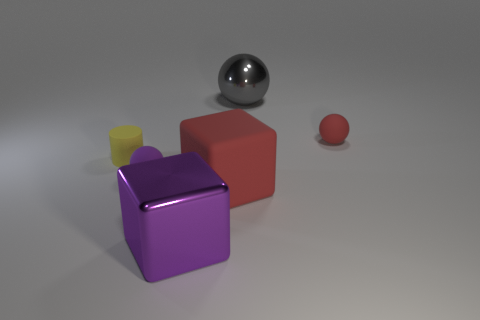Is the size of the purple rubber sphere the same as the purple block?
Keep it short and to the point. No. Is there a red matte thing of the same size as the yellow rubber thing?
Your answer should be compact. Yes. There is a ball to the left of the big matte cube; what is its material?
Offer a very short reply. Rubber. The cube that is made of the same material as the small red thing is what color?
Ensure brevity in your answer.  Red. How many shiny things are either purple cubes or large cyan spheres?
Provide a succinct answer. 1. There is a red matte object that is the same size as the gray ball; what is its shape?
Provide a succinct answer. Cube. What number of objects are either small things that are on the left side of the red block or big things that are in front of the tiny yellow cylinder?
Provide a succinct answer. 4. There is a gray thing that is the same size as the metallic cube; what material is it?
Ensure brevity in your answer.  Metal. How many other things are made of the same material as the big gray ball?
Ensure brevity in your answer.  1. Are there an equal number of large metallic cubes behind the large purple metal block and blocks behind the gray metallic sphere?
Provide a short and direct response. Yes. 